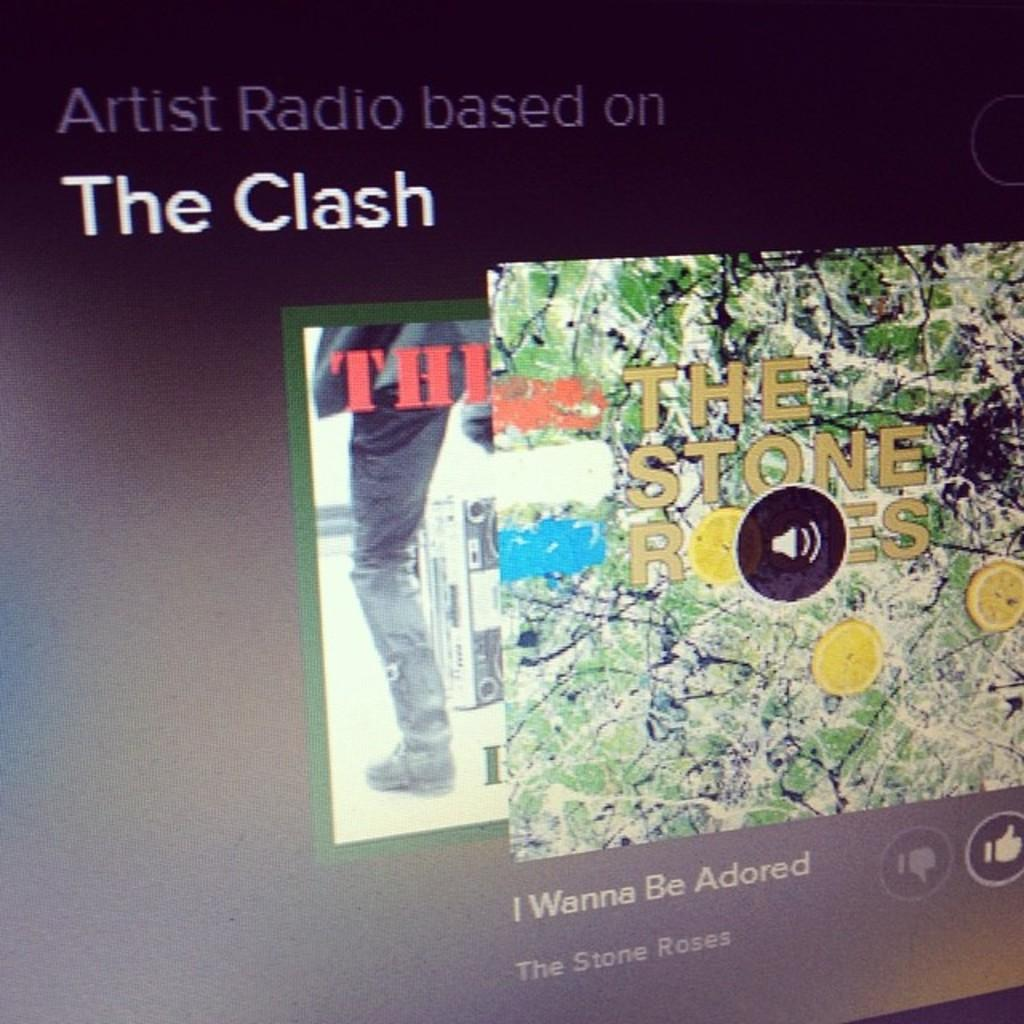<image>
Create a compact narrative representing the image presented. Screen showing a song by The Clash titled "I Wanna Be Adored". 